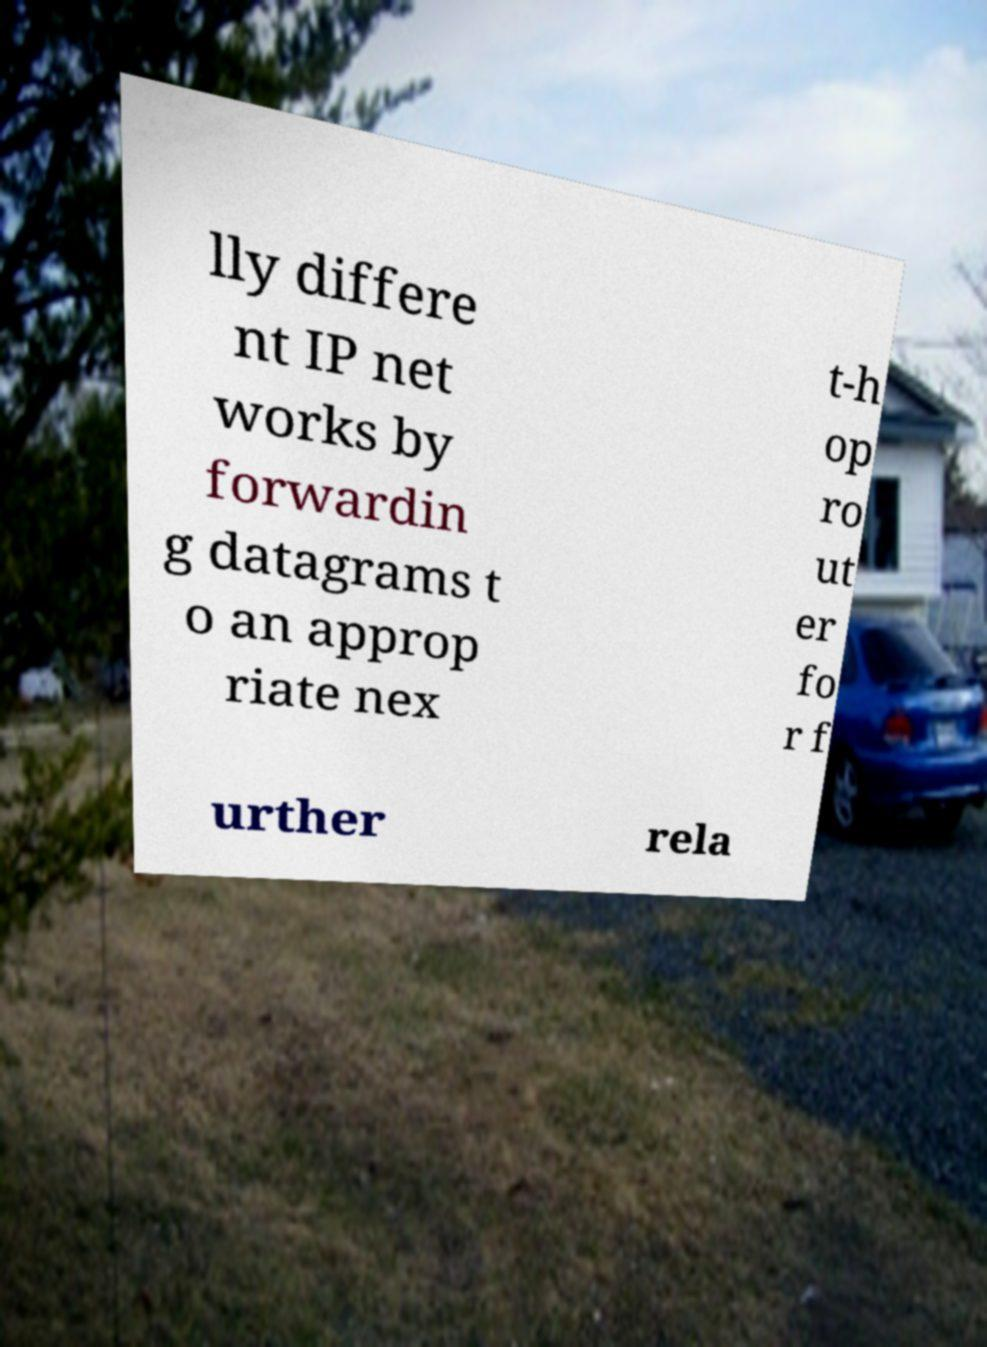What messages or text are displayed in this image? I need them in a readable, typed format. lly differe nt IP net works by forwardin g datagrams t o an approp riate nex t-h op ro ut er fo r f urther rela 